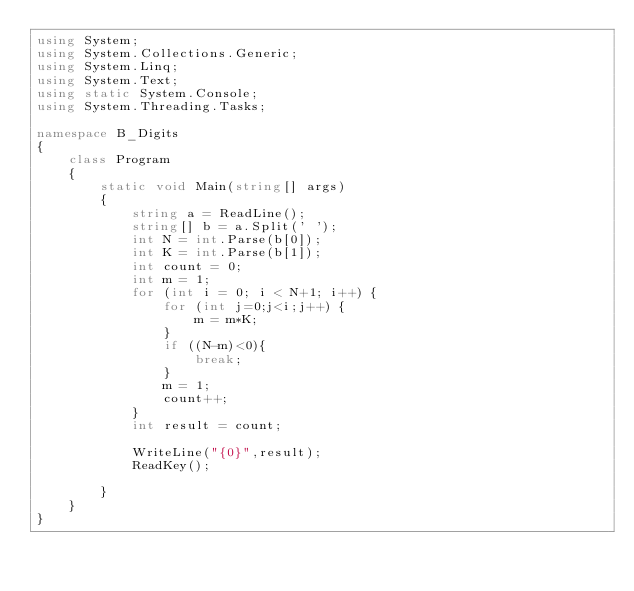Convert code to text. <code><loc_0><loc_0><loc_500><loc_500><_C#_>using System;
using System.Collections.Generic;
using System.Linq;
using System.Text;
using static System.Console;
using System.Threading.Tasks;

namespace B_Digits
{
    class Program
    {
        static void Main(string[] args)
        {
            string a = ReadLine();
            string[] b = a.Split(' ');
            int N = int.Parse(b[0]);
            int K = int.Parse(b[1]);
            int count = 0;
            int m = 1;
            for (int i = 0; i < N+1; i++) {
                for (int j=0;j<i;j++) {
                    m = m*K;
                }               
                if ((N-m)<0){
                    break;
                }
                m = 1;
                count++;
            }
            int result = count;
        
            WriteLine("{0}",result);
            ReadKey();

        }
    }
}
</code> 